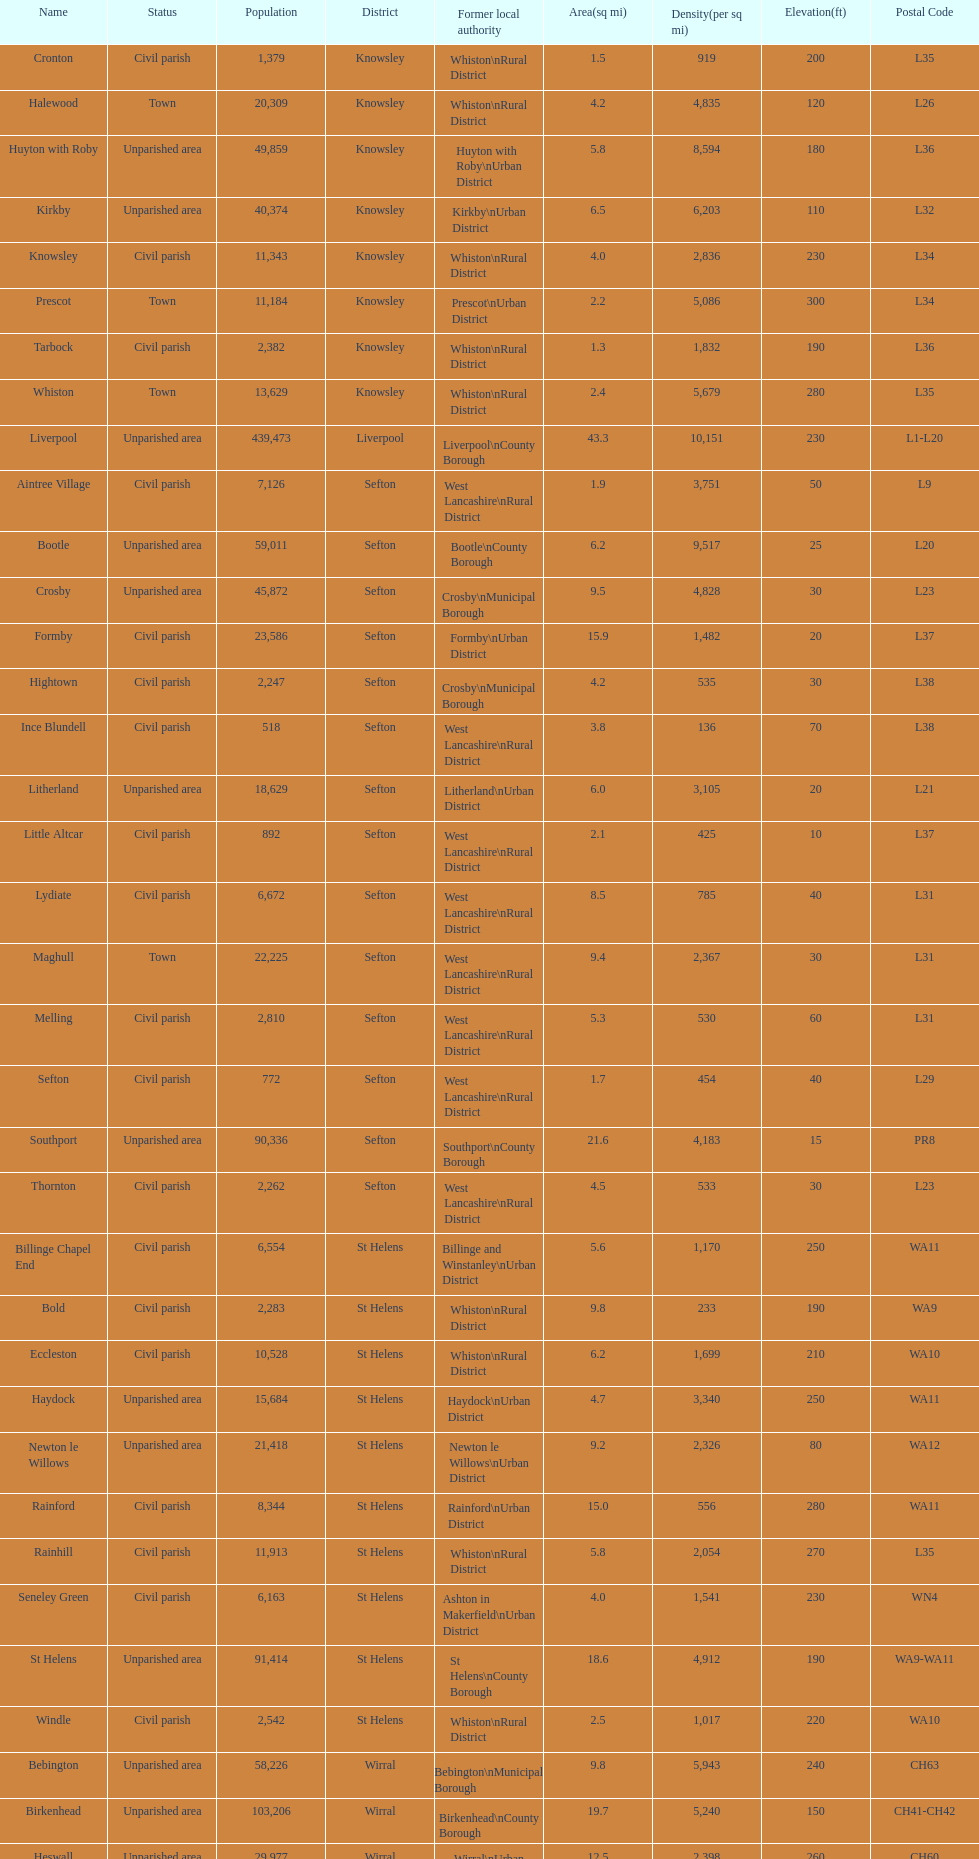How many areas are unparished areas? 15. 